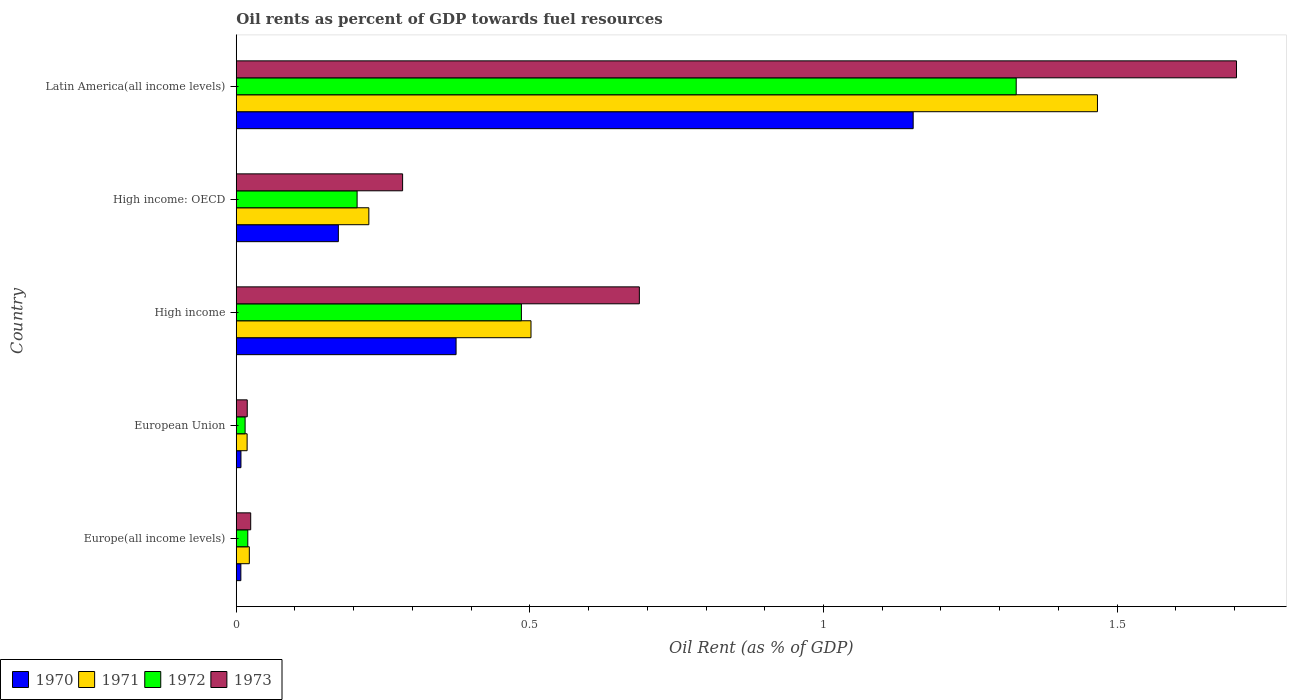How many different coloured bars are there?
Your response must be concise. 4. How many groups of bars are there?
Offer a terse response. 5. What is the label of the 2nd group of bars from the top?
Your response must be concise. High income: OECD. In how many cases, is the number of bars for a given country not equal to the number of legend labels?
Keep it short and to the point. 0. What is the oil rent in 1973 in European Union?
Provide a short and direct response. 0.02. Across all countries, what is the maximum oil rent in 1973?
Your answer should be very brief. 1.7. Across all countries, what is the minimum oil rent in 1973?
Offer a very short reply. 0.02. In which country was the oil rent in 1972 maximum?
Give a very brief answer. Latin America(all income levels). In which country was the oil rent in 1971 minimum?
Your response must be concise. European Union. What is the total oil rent in 1971 in the graph?
Your answer should be very brief. 2.24. What is the difference between the oil rent in 1970 in High income: OECD and that in Latin America(all income levels)?
Keep it short and to the point. -0.98. What is the difference between the oil rent in 1970 in Latin America(all income levels) and the oil rent in 1973 in High income?
Your answer should be compact. 0.47. What is the average oil rent in 1973 per country?
Make the answer very short. 0.54. What is the difference between the oil rent in 1973 and oil rent in 1972 in European Union?
Offer a terse response. 0. What is the ratio of the oil rent in 1972 in European Union to that in High income?
Make the answer very short. 0.03. Is the difference between the oil rent in 1973 in Europe(all income levels) and European Union greater than the difference between the oil rent in 1972 in Europe(all income levels) and European Union?
Offer a terse response. Yes. What is the difference between the highest and the second highest oil rent in 1971?
Give a very brief answer. 0.96. What is the difference between the highest and the lowest oil rent in 1972?
Offer a very short reply. 1.31. Is the sum of the oil rent in 1970 in European Union and Latin America(all income levels) greater than the maximum oil rent in 1972 across all countries?
Your response must be concise. No. What does the 2nd bar from the bottom in High income: OECD represents?
Provide a short and direct response. 1971. Is it the case that in every country, the sum of the oil rent in 1973 and oil rent in 1971 is greater than the oil rent in 1972?
Make the answer very short. Yes. How many bars are there?
Provide a succinct answer. 20. How many countries are there in the graph?
Ensure brevity in your answer.  5. What is the difference between two consecutive major ticks on the X-axis?
Offer a terse response. 0.5. Are the values on the major ticks of X-axis written in scientific E-notation?
Your response must be concise. No. Does the graph contain any zero values?
Provide a short and direct response. No. Where does the legend appear in the graph?
Keep it short and to the point. Bottom left. How many legend labels are there?
Offer a very short reply. 4. How are the legend labels stacked?
Your answer should be compact. Horizontal. What is the title of the graph?
Make the answer very short. Oil rents as percent of GDP towards fuel resources. Does "1972" appear as one of the legend labels in the graph?
Offer a terse response. Yes. What is the label or title of the X-axis?
Your answer should be very brief. Oil Rent (as % of GDP). What is the Oil Rent (as % of GDP) of 1970 in Europe(all income levels)?
Ensure brevity in your answer.  0.01. What is the Oil Rent (as % of GDP) of 1971 in Europe(all income levels)?
Give a very brief answer. 0.02. What is the Oil Rent (as % of GDP) of 1972 in Europe(all income levels)?
Your answer should be very brief. 0.02. What is the Oil Rent (as % of GDP) in 1973 in Europe(all income levels)?
Give a very brief answer. 0.02. What is the Oil Rent (as % of GDP) in 1970 in European Union?
Your response must be concise. 0.01. What is the Oil Rent (as % of GDP) of 1971 in European Union?
Your response must be concise. 0.02. What is the Oil Rent (as % of GDP) of 1972 in European Union?
Offer a terse response. 0.02. What is the Oil Rent (as % of GDP) of 1973 in European Union?
Provide a short and direct response. 0.02. What is the Oil Rent (as % of GDP) in 1970 in High income?
Give a very brief answer. 0.37. What is the Oil Rent (as % of GDP) of 1971 in High income?
Give a very brief answer. 0.5. What is the Oil Rent (as % of GDP) of 1972 in High income?
Ensure brevity in your answer.  0.49. What is the Oil Rent (as % of GDP) of 1973 in High income?
Make the answer very short. 0.69. What is the Oil Rent (as % of GDP) in 1970 in High income: OECD?
Your response must be concise. 0.17. What is the Oil Rent (as % of GDP) in 1971 in High income: OECD?
Offer a very short reply. 0.23. What is the Oil Rent (as % of GDP) of 1972 in High income: OECD?
Make the answer very short. 0.21. What is the Oil Rent (as % of GDP) in 1973 in High income: OECD?
Your answer should be compact. 0.28. What is the Oil Rent (as % of GDP) of 1970 in Latin America(all income levels)?
Ensure brevity in your answer.  1.15. What is the Oil Rent (as % of GDP) of 1971 in Latin America(all income levels)?
Offer a very short reply. 1.47. What is the Oil Rent (as % of GDP) of 1972 in Latin America(all income levels)?
Make the answer very short. 1.33. What is the Oil Rent (as % of GDP) of 1973 in Latin America(all income levels)?
Offer a very short reply. 1.7. Across all countries, what is the maximum Oil Rent (as % of GDP) of 1970?
Offer a very short reply. 1.15. Across all countries, what is the maximum Oil Rent (as % of GDP) in 1971?
Ensure brevity in your answer.  1.47. Across all countries, what is the maximum Oil Rent (as % of GDP) in 1972?
Make the answer very short. 1.33. Across all countries, what is the maximum Oil Rent (as % of GDP) of 1973?
Your answer should be compact. 1.7. Across all countries, what is the minimum Oil Rent (as % of GDP) of 1970?
Your answer should be very brief. 0.01. Across all countries, what is the minimum Oil Rent (as % of GDP) of 1971?
Keep it short and to the point. 0.02. Across all countries, what is the minimum Oil Rent (as % of GDP) of 1972?
Your response must be concise. 0.02. Across all countries, what is the minimum Oil Rent (as % of GDP) of 1973?
Make the answer very short. 0.02. What is the total Oil Rent (as % of GDP) in 1970 in the graph?
Offer a terse response. 1.72. What is the total Oil Rent (as % of GDP) in 1971 in the graph?
Make the answer very short. 2.24. What is the total Oil Rent (as % of GDP) of 1972 in the graph?
Give a very brief answer. 2.05. What is the total Oil Rent (as % of GDP) in 1973 in the graph?
Offer a terse response. 2.72. What is the difference between the Oil Rent (as % of GDP) of 1970 in Europe(all income levels) and that in European Union?
Offer a terse response. -0. What is the difference between the Oil Rent (as % of GDP) in 1971 in Europe(all income levels) and that in European Union?
Provide a short and direct response. 0. What is the difference between the Oil Rent (as % of GDP) in 1972 in Europe(all income levels) and that in European Union?
Give a very brief answer. 0. What is the difference between the Oil Rent (as % of GDP) in 1973 in Europe(all income levels) and that in European Union?
Provide a succinct answer. 0.01. What is the difference between the Oil Rent (as % of GDP) in 1970 in Europe(all income levels) and that in High income?
Your answer should be very brief. -0.37. What is the difference between the Oil Rent (as % of GDP) in 1971 in Europe(all income levels) and that in High income?
Provide a succinct answer. -0.48. What is the difference between the Oil Rent (as % of GDP) in 1972 in Europe(all income levels) and that in High income?
Make the answer very short. -0.47. What is the difference between the Oil Rent (as % of GDP) in 1973 in Europe(all income levels) and that in High income?
Ensure brevity in your answer.  -0.66. What is the difference between the Oil Rent (as % of GDP) in 1970 in Europe(all income levels) and that in High income: OECD?
Provide a succinct answer. -0.17. What is the difference between the Oil Rent (as % of GDP) in 1971 in Europe(all income levels) and that in High income: OECD?
Your response must be concise. -0.2. What is the difference between the Oil Rent (as % of GDP) in 1972 in Europe(all income levels) and that in High income: OECD?
Provide a short and direct response. -0.19. What is the difference between the Oil Rent (as % of GDP) of 1973 in Europe(all income levels) and that in High income: OECD?
Make the answer very short. -0.26. What is the difference between the Oil Rent (as % of GDP) of 1970 in Europe(all income levels) and that in Latin America(all income levels)?
Provide a short and direct response. -1.14. What is the difference between the Oil Rent (as % of GDP) of 1971 in Europe(all income levels) and that in Latin America(all income levels)?
Your response must be concise. -1.44. What is the difference between the Oil Rent (as % of GDP) in 1972 in Europe(all income levels) and that in Latin America(all income levels)?
Provide a succinct answer. -1.31. What is the difference between the Oil Rent (as % of GDP) in 1973 in Europe(all income levels) and that in Latin America(all income levels)?
Provide a succinct answer. -1.68. What is the difference between the Oil Rent (as % of GDP) in 1970 in European Union and that in High income?
Provide a succinct answer. -0.37. What is the difference between the Oil Rent (as % of GDP) of 1971 in European Union and that in High income?
Make the answer very short. -0.48. What is the difference between the Oil Rent (as % of GDP) of 1972 in European Union and that in High income?
Provide a short and direct response. -0.47. What is the difference between the Oil Rent (as % of GDP) of 1973 in European Union and that in High income?
Your answer should be very brief. -0.67. What is the difference between the Oil Rent (as % of GDP) in 1970 in European Union and that in High income: OECD?
Provide a short and direct response. -0.17. What is the difference between the Oil Rent (as % of GDP) in 1971 in European Union and that in High income: OECD?
Make the answer very short. -0.21. What is the difference between the Oil Rent (as % of GDP) of 1972 in European Union and that in High income: OECD?
Keep it short and to the point. -0.19. What is the difference between the Oil Rent (as % of GDP) in 1973 in European Union and that in High income: OECD?
Provide a short and direct response. -0.26. What is the difference between the Oil Rent (as % of GDP) of 1970 in European Union and that in Latin America(all income levels)?
Provide a short and direct response. -1.14. What is the difference between the Oil Rent (as % of GDP) of 1971 in European Union and that in Latin America(all income levels)?
Your answer should be compact. -1.45. What is the difference between the Oil Rent (as % of GDP) in 1972 in European Union and that in Latin America(all income levels)?
Your response must be concise. -1.31. What is the difference between the Oil Rent (as % of GDP) of 1973 in European Union and that in Latin America(all income levels)?
Provide a short and direct response. -1.68. What is the difference between the Oil Rent (as % of GDP) of 1970 in High income and that in High income: OECD?
Offer a terse response. 0.2. What is the difference between the Oil Rent (as % of GDP) in 1971 in High income and that in High income: OECD?
Ensure brevity in your answer.  0.28. What is the difference between the Oil Rent (as % of GDP) in 1972 in High income and that in High income: OECD?
Your answer should be compact. 0.28. What is the difference between the Oil Rent (as % of GDP) of 1973 in High income and that in High income: OECD?
Make the answer very short. 0.4. What is the difference between the Oil Rent (as % of GDP) of 1970 in High income and that in Latin America(all income levels)?
Offer a very short reply. -0.78. What is the difference between the Oil Rent (as % of GDP) of 1971 in High income and that in Latin America(all income levels)?
Make the answer very short. -0.96. What is the difference between the Oil Rent (as % of GDP) in 1972 in High income and that in Latin America(all income levels)?
Provide a succinct answer. -0.84. What is the difference between the Oil Rent (as % of GDP) in 1973 in High income and that in Latin America(all income levels)?
Provide a short and direct response. -1.02. What is the difference between the Oil Rent (as % of GDP) in 1970 in High income: OECD and that in Latin America(all income levels)?
Offer a terse response. -0.98. What is the difference between the Oil Rent (as % of GDP) of 1971 in High income: OECD and that in Latin America(all income levels)?
Give a very brief answer. -1.24. What is the difference between the Oil Rent (as % of GDP) in 1972 in High income: OECD and that in Latin America(all income levels)?
Your answer should be very brief. -1.12. What is the difference between the Oil Rent (as % of GDP) of 1973 in High income: OECD and that in Latin America(all income levels)?
Make the answer very short. -1.42. What is the difference between the Oil Rent (as % of GDP) in 1970 in Europe(all income levels) and the Oil Rent (as % of GDP) in 1971 in European Union?
Your answer should be compact. -0.01. What is the difference between the Oil Rent (as % of GDP) of 1970 in Europe(all income levels) and the Oil Rent (as % of GDP) of 1972 in European Union?
Keep it short and to the point. -0.01. What is the difference between the Oil Rent (as % of GDP) in 1970 in Europe(all income levels) and the Oil Rent (as % of GDP) in 1973 in European Union?
Ensure brevity in your answer.  -0.01. What is the difference between the Oil Rent (as % of GDP) of 1971 in Europe(all income levels) and the Oil Rent (as % of GDP) of 1972 in European Union?
Offer a very short reply. 0.01. What is the difference between the Oil Rent (as % of GDP) of 1971 in Europe(all income levels) and the Oil Rent (as % of GDP) of 1973 in European Union?
Ensure brevity in your answer.  0. What is the difference between the Oil Rent (as % of GDP) in 1972 in Europe(all income levels) and the Oil Rent (as % of GDP) in 1973 in European Union?
Ensure brevity in your answer.  0. What is the difference between the Oil Rent (as % of GDP) of 1970 in Europe(all income levels) and the Oil Rent (as % of GDP) of 1971 in High income?
Your answer should be compact. -0.49. What is the difference between the Oil Rent (as % of GDP) in 1970 in Europe(all income levels) and the Oil Rent (as % of GDP) in 1972 in High income?
Provide a short and direct response. -0.48. What is the difference between the Oil Rent (as % of GDP) in 1970 in Europe(all income levels) and the Oil Rent (as % of GDP) in 1973 in High income?
Provide a short and direct response. -0.68. What is the difference between the Oil Rent (as % of GDP) in 1971 in Europe(all income levels) and the Oil Rent (as % of GDP) in 1972 in High income?
Your answer should be compact. -0.46. What is the difference between the Oil Rent (as % of GDP) in 1971 in Europe(all income levels) and the Oil Rent (as % of GDP) in 1973 in High income?
Keep it short and to the point. -0.66. What is the difference between the Oil Rent (as % of GDP) in 1972 in Europe(all income levels) and the Oil Rent (as % of GDP) in 1973 in High income?
Offer a very short reply. -0.67. What is the difference between the Oil Rent (as % of GDP) of 1970 in Europe(all income levels) and the Oil Rent (as % of GDP) of 1971 in High income: OECD?
Provide a short and direct response. -0.22. What is the difference between the Oil Rent (as % of GDP) of 1970 in Europe(all income levels) and the Oil Rent (as % of GDP) of 1972 in High income: OECD?
Make the answer very short. -0.2. What is the difference between the Oil Rent (as % of GDP) in 1970 in Europe(all income levels) and the Oil Rent (as % of GDP) in 1973 in High income: OECD?
Ensure brevity in your answer.  -0.28. What is the difference between the Oil Rent (as % of GDP) in 1971 in Europe(all income levels) and the Oil Rent (as % of GDP) in 1972 in High income: OECD?
Ensure brevity in your answer.  -0.18. What is the difference between the Oil Rent (as % of GDP) of 1971 in Europe(all income levels) and the Oil Rent (as % of GDP) of 1973 in High income: OECD?
Provide a succinct answer. -0.26. What is the difference between the Oil Rent (as % of GDP) of 1972 in Europe(all income levels) and the Oil Rent (as % of GDP) of 1973 in High income: OECD?
Provide a succinct answer. -0.26. What is the difference between the Oil Rent (as % of GDP) of 1970 in Europe(all income levels) and the Oil Rent (as % of GDP) of 1971 in Latin America(all income levels)?
Offer a very short reply. -1.46. What is the difference between the Oil Rent (as % of GDP) in 1970 in Europe(all income levels) and the Oil Rent (as % of GDP) in 1972 in Latin America(all income levels)?
Ensure brevity in your answer.  -1.32. What is the difference between the Oil Rent (as % of GDP) in 1970 in Europe(all income levels) and the Oil Rent (as % of GDP) in 1973 in Latin America(all income levels)?
Provide a short and direct response. -1.7. What is the difference between the Oil Rent (as % of GDP) in 1971 in Europe(all income levels) and the Oil Rent (as % of GDP) in 1972 in Latin America(all income levels)?
Your answer should be compact. -1.31. What is the difference between the Oil Rent (as % of GDP) in 1971 in Europe(all income levels) and the Oil Rent (as % of GDP) in 1973 in Latin America(all income levels)?
Make the answer very short. -1.68. What is the difference between the Oil Rent (as % of GDP) of 1972 in Europe(all income levels) and the Oil Rent (as % of GDP) of 1973 in Latin America(all income levels)?
Provide a short and direct response. -1.68. What is the difference between the Oil Rent (as % of GDP) in 1970 in European Union and the Oil Rent (as % of GDP) in 1971 in High income?
Offer a terse response. -0.49. What is the difference between the Oil Rent (as % of GDP) of 1970 in European Union and the Oil Rent (as % of GDP) of 1972 in High income?
Ensure brevity in your answer.  -0.48. What is the difference between the Oil Rent (as % of GDP) in 1970 in European Union and the Oil Rent (as % of GDP) in 1973 in High income?
Your response must be concise. -0.68. What is the difference between the Oil Rent (as % of GDP) of 1971 in European Union and the Oil Rent (as % of GDP) of 1972 in High income?
Your answer should be very brief. -0.47. What is the difference between the Oil Rent (as % of GDP) of 1971 in European Union and the Oil Rent (as % of GDP) of 1973 in High income?
Provide a short and direct response. -0.67. What is the difference between the Oil Rent (as % of GDP) of 1972 in European Union and the Oil Rent (as % of GDP) of 1973 in High income?
Ensure brevity in your answer.  -0.67. What is the difference between the Oil Rent (as % of GDP) of 1970 in European Union and the Oil Rent (as % of GDP) of 1971 in High income: OECD?
Ensure brevity in your answer.  -0.22. What is the difference between the Oil Rent (as % of GDP) of 1970 in European Union and the Oil Rent (as % of GDP) of 1972 in High income: OECD?
Offer a terse response. -0.2. What is the difference between the Oil Rent (as % of GDP) of 1970 in European Union and the Oil Rent (as % of GDP) of 1973 in High income: OECD?
Provide a succinct answer. -0.28. What is the difference between the Oil Rent (as % of GDP) of 1971 in European Union and the Oil Rent (as % of GDP) of 1972 in High income: OECD?
Give a very brief answer. -0.19. What is the difference between the Oil Rent (as % of GDP) of 1971 in European Union and the Oil Rent (as % of GDP) of 1973 in High income: OECD?
Offer a very short reply. -0.26. What is the difference between the Oil Rent (as % of GDP) in 1972 in European Union and the Oil Rent (as % of GDP) in 1973 in High income: OECD?
Make the answer very short. -0.27. What is the difference between the Oil Rent (as % of GDP) in 1970 in European Union and the Oil Rent (as % of GDP) in 1971 in Latin America(all income levels)?
Provide a short and direct response. -1.46. What is the difference between the Oil Rent (as % of GDP) of 1970 in European Union and the Oil Rent (as % of GDP) of 1972 in Latin America(all income levels)?
Keep it short and to the point. -1.32. What is the difference between the Oil Rent (as % of GDP) of 1970 in European Union and the Oil Rent (as % of GDP) of 1973 in Latin America(all income levels)?
Keep it short and to the point. -1.7. What is the difference between the Oil Rent (as % of GDP) of 1971 in European Union and the Oil Rent (as % of GDP) of 1972 in Latin America(all income levels)?
Provide a succinct answer. -1.31. What is the difference between the Oil Rent (as % of GDP) of 1971 in European Union and the Oil Rent (as % of GDP) of 1973 in Latin America(all income levels)?
Provide a short and direct response. -1.68. What is the difference between the Oil Rent (as % of GDP) in 1972 in European Union and the Oil Rent (as % of GDP) in 1973 in Latin America(all income levels)?
Your answer should be very brief. -1.69. What is the difference between the Oil Rent (as % of GDP) in 1970 in High income and the Oil Rent (as % of GDP) in 1971 in High income: OECD?
Keep it short and to the point. 0.15. What is the difference between the Oil Rent (as % of GDP) of 1970 in High income and the Oil Rent (as % of GDP) of 1972 in High income: OECD?
Make the answer very short. 0.17. What is the difference between the Oil Rent (as % of GDP) in 1970 in High income and the Oil Rent (as % of GDP) in 1973 in High income: OECD?
Ensure brevity in your answer.  0.09. What is the difference between the Oil Rent (as % of GDP) in 1971 in High income and the Oil Rent (as % of GDP) in 1972 in High income: OECD?
Your answer should be compact. 0.3. What is the difference between the Oil Rent (as % of GDP) of 1971 in High income and the Oil Rent (as % of GDP) of 1973 in High income: OECD?
Make the answer very short. 0.22. What is the difference between the Oil Rent (as % of GDP) in 1972 in High income and the Oil Rent (as % of GDP) in 1973 in High income: OECD?
Your response must be concise. 0.2. What is the difference between the Oil Rent (as % of GDP) in 1970 in High income and the Oil Rent (as % of GDP) in 1971 in Latin America(all income levels)?
Provide a succinct answer. -1.09. What is the difference between the Oil Rent (as % of GDP) in 1970 in High income and the Oil Rent (as % of GDP) in 1972 in Latin America(all income levels)?
Your response must be concise. -0.95. What is the difference between the Oil Rent (as % of GDP) of 1970 in High income and the Oil Rent (as % of GDP) of 1973 in Latin America(all income levels)?
Ensure brevity in your answer.  -1.33. What is the difference between the Oil Rent (as % of GDP) in 1971 in High income and the Oil Rent (as % of GDP) in 1972 in Latin America(all income levels)?
Keep it short and to the point. -0.83. What is the difference between the Oil Rent (as % of GDP) of 1971 in High income and the Oil Rent (as % of GDP) of 1973 in Latin America(all income levels)?
Your answer should be very brief. -1.2. What is the difference between the Oil Rent (as % of GDP) in 1972 in High income and the Oil Rent (as % of GDP) in 1973 in Latin America(all income levels)?
Keep it short and to the point. -1.22. What is the difference between the Oil Rent (as % of GDP) in 1970 in High income: OECD and the Oil Rent (as % of GDP) in 1971 in Latin America(all income levels)?
Your response must be concise. -1.29. What is the difference between the Oil Rent (as % of GDP) in 1970 in High income: OECD and the Oil Rent (as % of GDP) in 1972 in Latin America(all income levels)?
Provide a succinct answer. -1.15. What is the difference between the Oil Rent (as % of GDP) of 1970 in High income: OECD and the Oil Rent (as % of GDP) of 1973 in Latin America(all income levels)?
Provide a short and direct response. -1.53. What is the difference between the Oil Rent (as % of GDP) in 1971 in High income: OECD and the Oil Rent (as % of GDP) in 1972 in Latin America(all income levels)?
Offer a very short reply. -1.1. What is the difference between the Oil Rent (as % of GDP) of 1971 in High income: OECD and the Oil Rent (as % of GDP) of 1973 in Latin America(all income levels)?
Your answer should be very brief. -1.48. What is the difference between the Oil Rent (as % of GDP) in 1972 in High income: OECD and the Oil Rent (as % of GDP) in 1973 in Latin America(all income levels)?
Offer a terse response. -1.5. What is the average Oil Rent (as % of GDP) of 1970 per country?
Your answer should be very brief. 0.34. What is the average Oil Rent (as % of GDP) of 1971 per country?
Make the answer very short. 0.45. What is the average Oil Rent (as % of GDP) of 1972 per country?
Your answer should be very brief. 0.41. What is the average Oil Rent (as % of GDP) in 1973 per country?
Offer a terse response. 0.54. What is the difference between the Oil Rent (as % of GDP) in 1970 and Oil Rent (as % of GDP) in 1971 in Europe(all income levels)?
Make the answer very short. -0.01. What is the difference between the Oil Rent (as % of GDP) in 1970 and Oil Rent (as % of GDP) in 1972 in Europe(all income levels)?
Your answer should be very brief. -0.01. What is the difference between the Oil Rent (as % of GDP) in 1970 and Oil Rent (as % of GDP) in 1973 in Europe(all income levels)?
Ensure brevity in your answer.  -0.02. What is the difference between the Oil Rent (as % of GDP) of 1971 and Oil Rent (as % of GDP) of 1972 in Europe(all income levels)?
Provide a short and direct response. 0. What is the difference between the Oil Rent (as % of GDP) in 1971 and Oil Rent (as % of GDP) in 1973 in Europe(all income levels)?
Your answer should be compact. -0. What is the difference between the Oil Rent (as % of GDP) in 1972 and Oil Rent (as % of GDP) in 1973 in Europe(all income levels)?
Your answer should be compact. -0.01. What is the difference between the Oil Rent (as % of GDP) in 1970 and Oil Rent (as % of GDP) in 1971 in European Union?
Provide a succinct answer. -0.01. What is the difference between the Oil Rent (as % of GDP) of 1970 and Oil Rent (as % of GDP) of 1972 in European Union?
Your response must be concise. -0.01. What is the difference between the Oil Rent (as % of GDP) of 1970 and Oil Rent (as % of GDP) of 1973 in European Union?
Offer a very short reply. -0.01. What is the difference between the Oil Rent (as % of GDP) in 1971 and Oil Rent (as % of GDP) in 1972 in European Union?
Ensure brevity in your answer.  0. What is the difference between the Oil Rent (as % of GDP) in 1971 and Oil Rent (as % of GDP) in 1973 in European Union?
Give a very brief answer. -0. What is the difference between the Oil Rent (as % of GDP) in 1972 and Oil Rent (as % of GDP) in 1973 in European Union?
Offer a terse response. -0. What is the difference between the Oil Rent (as % of GDP) in 1970 and Oil Rent (as % of GDP) in 1971 in High income?
Make the answer very short. -0.13. What is the difference between the Oil Rent (as % of GDP) of 1970 and Oil Rent (as % of GDP) of 1972 in High income?
Your answer should be compact. -0.11. What is the difference between the Oil Rent (as % of GDP) of 1970 and Oil Rent (as % of GDP) of 1973 in High income?
Provide a short and direct response. -0.31. What is the difference between the Oil Rent (as % of GDP) of 1971 and Oil Rent (as % of GDP) of 1972 in High income?
Give a very brief answer. 0.02. What is the difference between the Oil Rent (as % of GDP) of 1971 and Oil Rent (as % of GDP) of 1973 in High income?
Provide a short and direct response. -0.18. What is the difference between the Oil Rent (as % of GDP) of 1972 and Oil Rent (as % of GDP) of 1973 in High income?
Keep it short and to the point. -0.2. What is the difference between the Oil Rent (as % of GDP) of 1970 and Oil Rent (as % of GDP) of 1971 in High income: OECD?
Offer a very short reply. -0.05. What is the difference between the Oil Rent (as % of GDP) in 1970 and Oil Rent (as % of GDP) in 1972 in High income: OECD?
Keep it short and to the point. -0.03. What is the difference between the Oil Rent (as % of GDP) in 1970 and Oil Rent (as % of GDP) in 1973 in High income: OECD?
Give a very brief answer. -0.11. What is the difference between the Oil Rent (as % of GDP) in 1971 and Oil Rent (as % of GDP) in 1973 in High income: OECD?
Your response must be concise. -0.06. What is the difference between the Oil Rent (as % of GDP) of 1972 and Oil Rent (as % of GDP) of 1973 in High income: OECD?
Provide a short and direct response. -0.08. What is the difference between the Oil Rent (as % of GDP) of 1970 and Oil Rent (as % of GDP) of 1971 in Latin America(all income levels)?
Provide a short and direct response. -0.31. What is the difference between the Oil Rent (as % of GDP) of 1970 and Oil Rent (as % of GDP) of 1972 in Latin America(all income levels)?
Give a very brief answer. -0.18. What is the difference between the Oil Rent (as % of GDP) of 1970 and Oil Rent (as % of GDP) of 1973 in Latin America(all income levels)?
Give a very brief answer. -0.55. What is the difference between the Oil Rent (as % of GDP) of 1971 and Oil Rent (as % of GDP) of 1972 in Latin America(all income levels)?
Provide a succinct answer. 0.14. What is the difference between the Oil Rent (as % of GDP) in 1971 and Oil Rent (as % of GDP) in 1973 in Latin America(all income levels)?
Keep it short and to the point. -0.24. What is the difference between the Oil Rent (as % of GDP) in 1972 and Oil Rent (as % of GDP) in 1973 in Latin America(all income levels)?
Provide a succinct answer. -0.38. What is the ratio of the Oil Rent (as % of GDP) of 1970 in Europe(all income levels) to that in European Union?
Your answer should be very brief. 0.98. What is the ratio of the Oil Rent (as % of GDP) in 1971 in Europe(all income levels) to that in European Union?
Make the answer very short. 1.2. What is the ratio of the Oil Rent (as % of GDP) in 1972 in Europe(all income levels) to that in European Union?
Offer a terse response. 1.3. What is the ratio of the Oil Rent (as % of GDP) in 1973 in Europe(all income levels) to that in European Union?
Your response must be concise. 1.31. What is the ratio of the Oil Rent (as % of GDP) in 1970 in Europe(all income levels) to that in High income?
Ensure brevity in your answer.  0.02. What is the ratio of the Oil Rent (as % of GDP) of 1971 in Europe(all income levels) to that in High income?
Provide a succinct answer. 0.04. What is the ratio of the Oil Rent (as % of GDP) in 1972 in Europe(all income levels) to that in High income?
Provide a short and direct response. 0.04. What is the ratio of the Oil Rent (as % of GDP) of 1973 in Europe(all income levels) to that in High income?
Give a very brief answer. 0.04. What is the ratio of the Oil Rent (as % of GDP) in 1970 in Europe(all income levels) to that in High income: OECD?
Your answer should be compact. 0.05. What is the ratio of the Oil Rent (as % of GDP) in 1971 in Europe(all income levels) to that in High income: OECD?
Ensure brevity in your answer.  0.1. What is the ratio of the Oil Rent (as % of GDP) of 1972 in Europe(all income levels) to that in High income: OECD?
Offer a terse response. 0.1. What is the ratio of the Oil Rent (as % of GDP) of 1973 in Europe(all income levels) to that in High income: OECD?
Your response must be concise. 0.09. What is the ratio of the Oil Rent (as % of GDP) in 1970 in Europe(all income levels) to that in Latin America(all income levels)?
Your answer should be very brief. 0.01. What is the ratio of the Oil Rent (as % of GDP) in 1971 in Europe(all income levels) to that in Latin America(all income levels)?
Provide a succinct answer. 0.02. What is the ratio of the Oil Rent (as % of GDP) of 1972 in Europe(all income levels) to that in Latin America(all income levels)?
Your response must be concise. 0.01. What is the ratio of the Oil Rent (as % of GDP) of 1973 in Europe(all income levels) to that in Latin America(all income levels)?
Offer a very short reply. 0.01. What is the ratio of the Oil Rent (as % of GDP) in 1970 in European Union to that in High income?
Provide a short and direct response. 0.02. What is the ratio of the Oil Rent (as % of GDP) of 1971 in European Union to that in High income?
Make the answer very short. 0.04. What is the ratio of the Oil Rent (as % of GDP) in 1972 in European Union to that in High income?
Your answer should be very brief. 0.03. What is the ratio of the Oil Rent (as % of GDP) in 1973 in European Union to that in High income?
Provide a succinct answer. 0.03. What is the ratio of the Oil Rent (as % of GDP) of 1970 in European Union to that in High income: OECD?
Your answer should be compact. 0.05. What is the ratio of the Oil Rent (as % of GDP) in 1971 in European Union to that in High income: OECD?
Give a very brief answer. 0.08. What is the ratio of the Oil Rent (as % of GDP) of 1972 in European Union to that in High income: OECD?
Provide a short and direct response. 0.07. What is the ratio of the Oil Rent (as % of GDP) of 1973 in European Union to that in High income: OECD?
Give a very brief answer. 0.07. What is the ratio of the Oil Rent (as % of GDP) in 1970 in European Union to that in Latin America(all income levels)?
Make the answer very short. 0.01. What is the ratio of the Oil Rent (as % of GDP) in 1971 in European Union to that in Latin America(all income levels)?
Offer a very short reply. 0.01. What is the ratio of the Oil Rent (as % of GDP) of 1972 in European Union to that in Latin America(all income levels)?
Make the answer very short. 0.01. What is the ratio of the Oil Rent (as % of GDP) in 1973 in European Union to that in Latin America(all income levels)?
Offer a very short reply. 0.01. What is the ratio of the Oil Rent (as % of GDP) in 1970 in High income to that in High income: OECD?
Provide a short and direct response. 2.15. What is the ratio of the Oil Rent (as % of GDP) of 1971 in High income to that in High income: OECD?
Make the answer very short. 2.22. What is the ratio of the Oil Rent (as % of GDP) in 1972 in High income to that in High income: OECD?
Provide a succinct answer. 2.36. What is the ratio of the Oil Rent (as % of GDP) of 1973 in High income to that in High income: OECD?
Keep it short and to the point. 2.42. What is the ratio of the Oil Rent (as % of GDP) of 1970 in High income to that in Latin America(all income levels)?
Offer a terse response. 0.32. What is the ratio of the Oil Rent (as % of GDP) in 1971 in High income to that in Latin America(all income levels)?
Your answer should be very brief. 0.34. What is the ratio of the Oil Rent (as % of GDP) in 1972 in High income to that in Latin America(all income levels)?
Keep it short and to the point. 0.37. What is the ratio of the Oil Rent (as % of GDP) in 1973 in High income to that in Latin America(all income levels)?
Your answer should be compact. 0.4. What is the ratio of the Oil Rent (as % of GDP) of 1970 in High income: OECD to that in Latin America(all income levels)?
Offer a terse response. 0.15. What is the ratio of the Oil Rent (as % of GDP) of 1971 in High income: OECD to that in Latin America(all income levels)?
Ensure brevity in your answer.  0.15. What is the ratio of the Oil Rent (as % of GDP) of 1972 in High income: OECD to that in Latin America(all income levels)?
Make the answer very short. 0.15. What is the ratio of the Oil Rent (as % of GDP) in 1973 in High income: OECD to that in Latin America(all income levels)?
Offer a terse response. 0.17. What is the difference between the highest and the second highest Oil Rent (as % of GDP) of 1970?
Offer a terse response. 0.78. What is the difference between the highest and the second highest Oil Rent (as % of GDP) in 1971?
Make the answer very short. 0.96. What is the difference between the highest and the second highest Oil Rent (as % of GDP) in 1972?
Provide a succinct answer. 0.84. What is the difference between the highest and the second highest Oil Rent (as % of GDP) in 1973?
Provide a short and direct response. 1.02. What is the difference between the highest and the lowest Oil Rent (as % of GDP) of 1970?
Provide a succinct answer. 1.14. What is the difference between the highest and the lowest Oil Rent (as % of GDP) in 1971?
Provide a succinct answer. 1.45. What is the difference between the highest and the lowest Oil Rent (as % of GDP) in 1972?
Ensure brevity in your answer.  1.31. What is the difference between the highest and the lowest Oil Rent (as % of GDP) in 1973?
Your answer should be very brief. 1.68. 